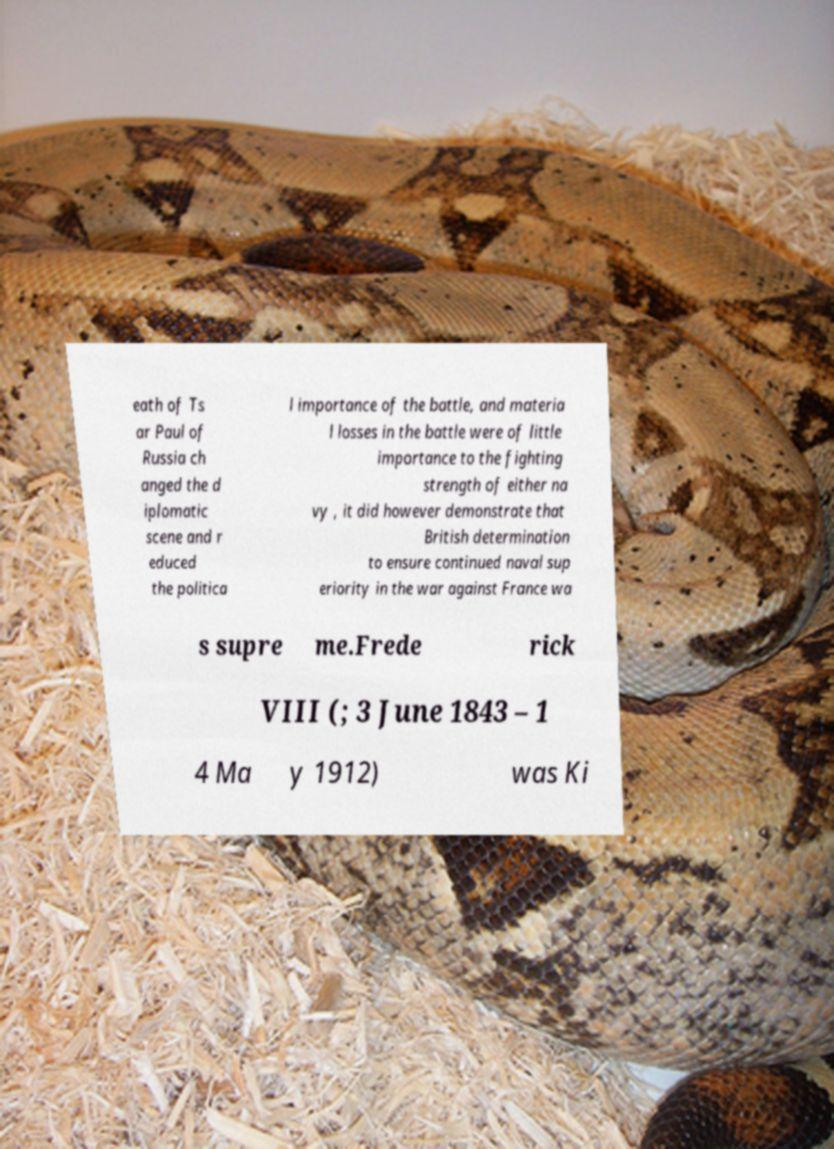Please identify and transcribe the text found in this image. eath of Ts ar Paul of Russia ch anged the d iplomatic scene and r educed the politica l importance of the battle, and materia l losses in the battle were of little importance to the fighting strength of either na vy , it did however demonstrate that British determination to ensure continued naval sup eriority in the war against France wa s supre me.Frede rick VIII (; 3 June 1843 – 1 4 Ma y 1912) was Ki 